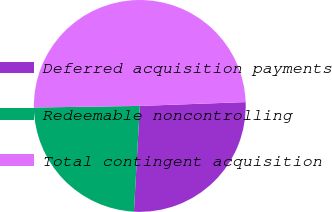Convert chart to OTSL. <chart><loc_0><loc_0><loc_500><loc_500><pie_chart><fcel>Deferred acquisition payments<fcel>Redeemable noncontrolling<fcel>Total contingent acquisition<nl><fcel>26.46%<fcel>23.88%<fcel>49.67%<nl></chart> 